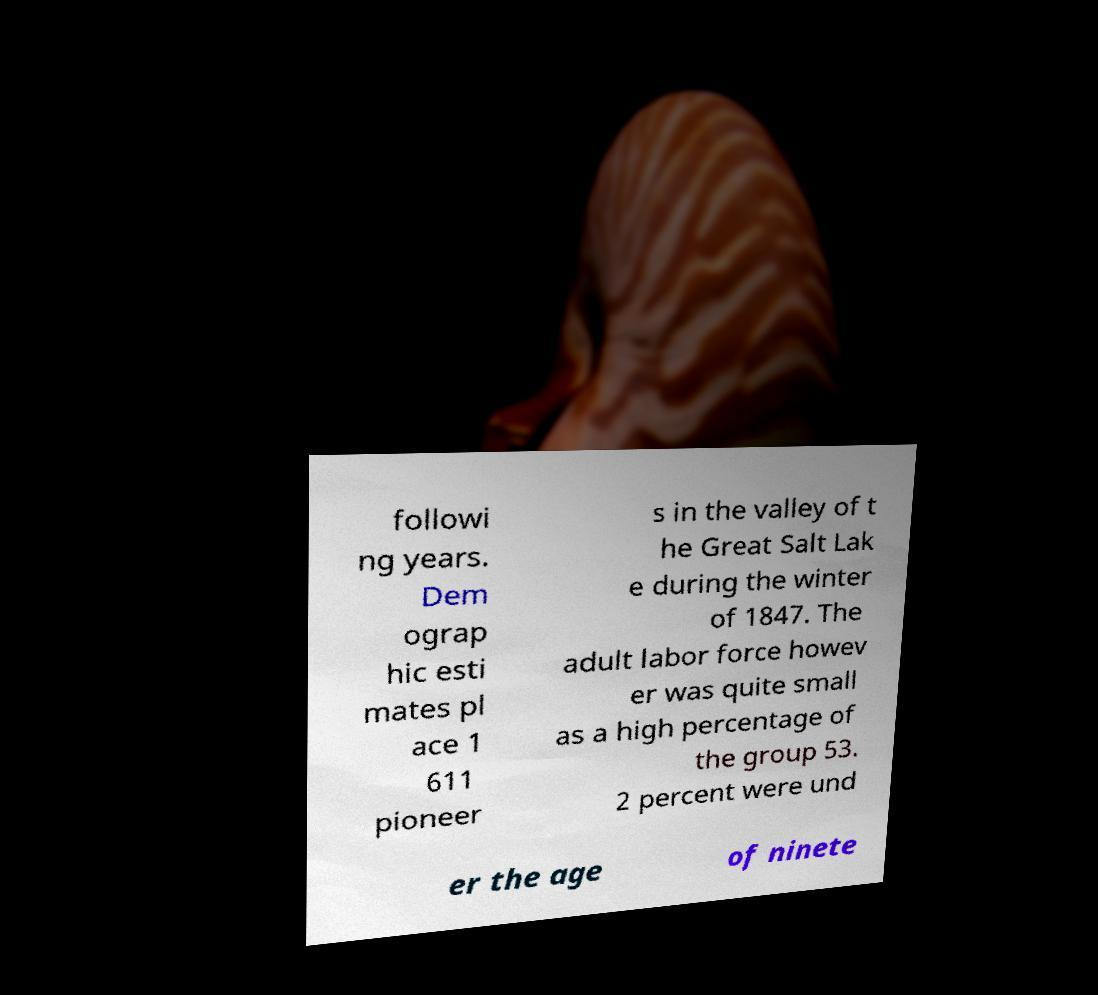Can you read and provide the text displayed in the image?This photo seems to have some interesting text. Can you extract and type it out for me? followi ng years. Dem ograp hic esti mates pl ace 1 611 pioneer s in the valley of t he Great Salt Lak e during the winter of 1847. The adult labor force howev er was quite small as a high percentage of the group 53. 2 percent were und er the age of ninete 